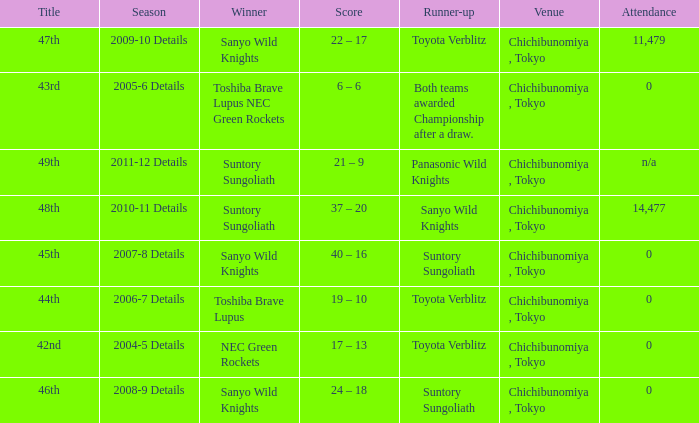What is the Attendance number for the title of 44th? 0.0. 